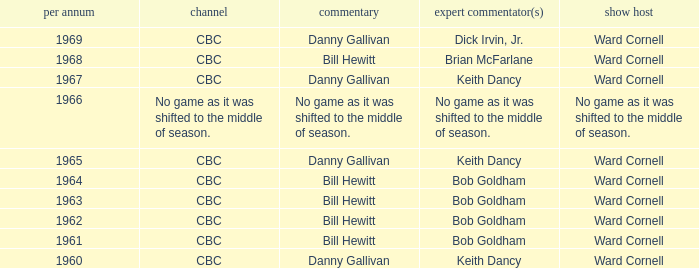Who did the play-by-play on the CBC network before 1961? Danny Gallivan. 